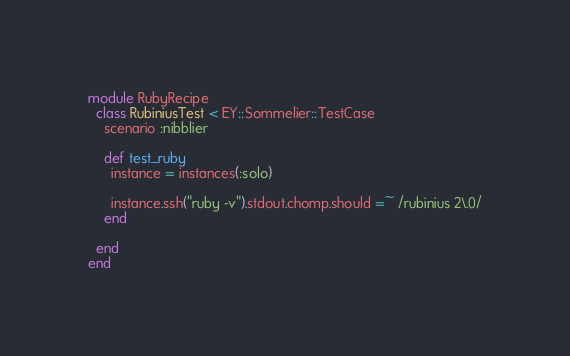<code> <loc_0><loc_0><loc_500><loc_500><_Ruby_>module RubyRecipe
  class RubiniusTest < EY::Sommelier::TestCase
    scenario :nibblier

    def test_ruby
      instance = instances(:solo)

      instance.ssh("ruby -v").stdout.chomp.should =~ /rubinius 2\.0/
    end

  end
end
</code> 